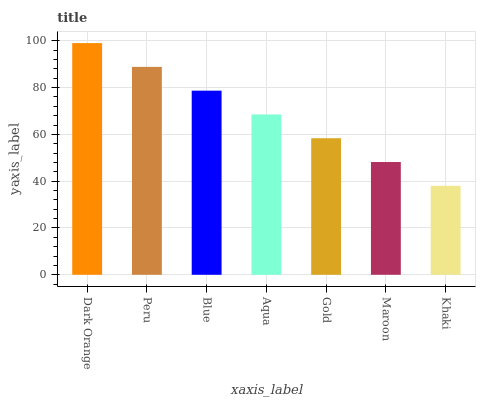Is Khaki the minimum?
Answer yes or no. Yes. Is Dark Orange the maximum?
Answer yes or no. Yes. Is Peru the minimum?
Answer yes or no. No. Is Peru the maximum?
Answer yes or no. No. Is Dark Orange greater than Peru?
Answer yes or no. Yes. Is Peru less than Dark Orange?
Answer yes or no. Yes. Is Peru greater than Dark Orange?
Answer yes or no. No. Is Dark Orange less than Peru?
Answer yes or no. No. Is Aqua the high median?
Answer yes or no. Yes. Is Aqua the low median?
Answer yes or no. Yes. Is Peru the high median?
Answer yes or no. No. Is Khaki the low median?
Answer yes or no. No. 